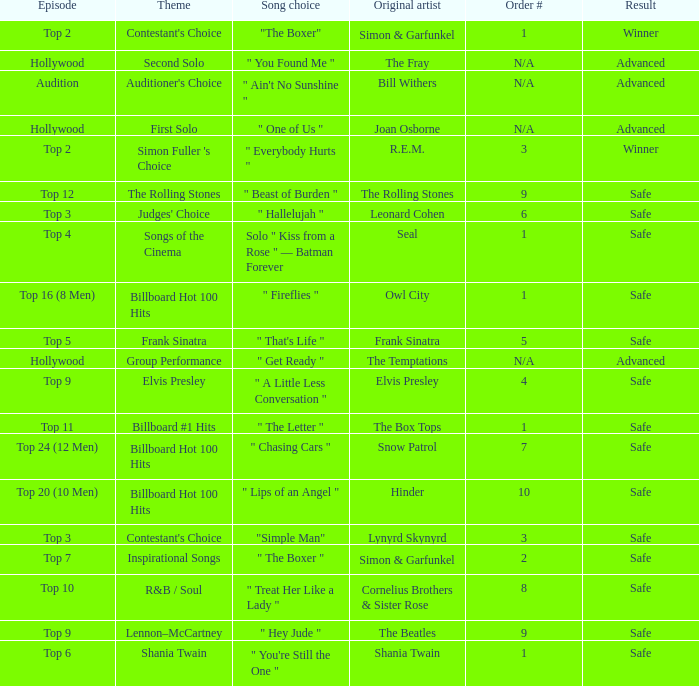What is the outcome for the original artist joan osborne? Advanced. 